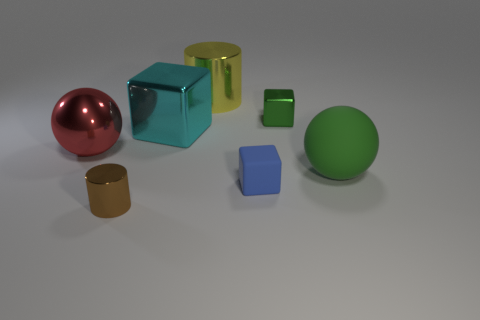What is the material of the object that is the same color as the rubber ball?
Offer a terse response. Metal. Are there any large rubber objects of the same shape as the big red shiny object?
Make the answer very short. Yes. Is the material of the sphere to the right of the large block the same as the cylinder in front of the tiny green shiny object?
Your answer should be compact. No. There is a ball on the left side of the big sphere that is to the right of the green cube right of the small blue cube; what is its size?
Provide a succinct answer. Large. There is a green cube that is the same size as the brown shiny thing; what is it made of?
Offer a terse response. Metal. Are there any brown things that have the same size as the blue matte thing?
Your answer should be compact. Yes. Is the shape of the brown thing the same as the large yellow object?
Your answer should be very brief. Yes. Are there any big yellow shiny cylinders on the left side of the big sphere right of the metal thing in front of the large red thing?
Your answer should be very brief. Yes. How many other things are the same color as the small cylinder?
Offer a very short reply. 0. Do the sphere to the right of the small brown metal object and the rubber thing that is to the left of the large green thing have the same size?
Give a very brief answer. No. 